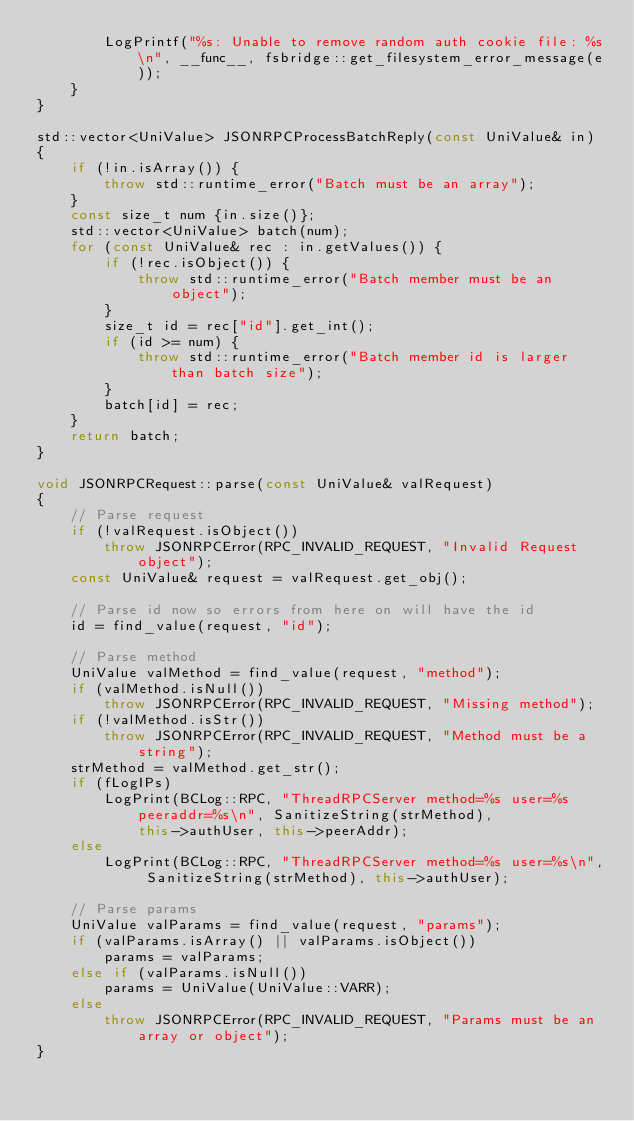<code> <loc_0><loc_0><loc_500><loc_500><_C++_>        LogPrintf("%s: Unable to remove random auth cookie file: %s\n", __func__, fsbridge::get_filesystem_error_message(e));
    }
}

std::vector<UniValue> JSONRPCProcessBatchReply(const UniValue& in)
{
    if (!in.isArray()) {
        throw std::runtime_error("Batch must be an array");
    }
    const size_t num {in.size()};
    std::vector<UniValue> batch(num);
    for (const UniValue& rec : in.getValues()) {
        if (!rec.isObject()) {
            throw std::runtime_error("Batch member must be an object");
        }
        size_t id = rec["id"].get_int();
        if (id >= num) {
            throw std::runtime_error("Batch member id is larger than batch size");
        }
        batch[id] = rec;
    }
    return batch;
}

void JSONRPCRequest::parse(const UniValue& valRequest)
{
    // Parse request
    if (!valRequest.isObject())
        throw JSONRPCError(RPC_INVALID_REQUEST, "Invalid Request object");
    const UniValue& request = valRequest.get_obj();

    // Parse id now so errors from here on will have the id
    id = find_value(request, "id");

    // Parse method
    UniValue valMethod = find_value(request, "method");
    if (valMethod.isNull())
        throw JSONRPCError(RPC_INVALID_REQUEST, "Missing method");
    if (!valMethod.isStr())
        throw JSONRPCError(RPC_INVALID_REQUEST, "Method must be a string");
    strMethod = valMethod.get_str();
    if (fLogIPs)
        LogPrint(BCLog::RPC, "ThreadRPCServer method=%s user=%s peeraddr=%s\n", SanitizeString(strMethod),
            this->authUser, this->peerAddr);
    else
        LogPrint(BCLog::RPC, "ThreadRPCServer method=%s user=%s\n", SanitizeString(strMethod), this->authUser);

    // Parse params
    UniValue valParams = find_value(request, "params");
    if (valParams.isArray() || valParams.isObject())
        params = valParams;
    else if (valParams.isNull())
        params = UniValue(UniValue::VARR);
    else
        throw JSONRPCError(RPC_INVALID_REQUEST, "Params must be an array or object");
}
</code> 